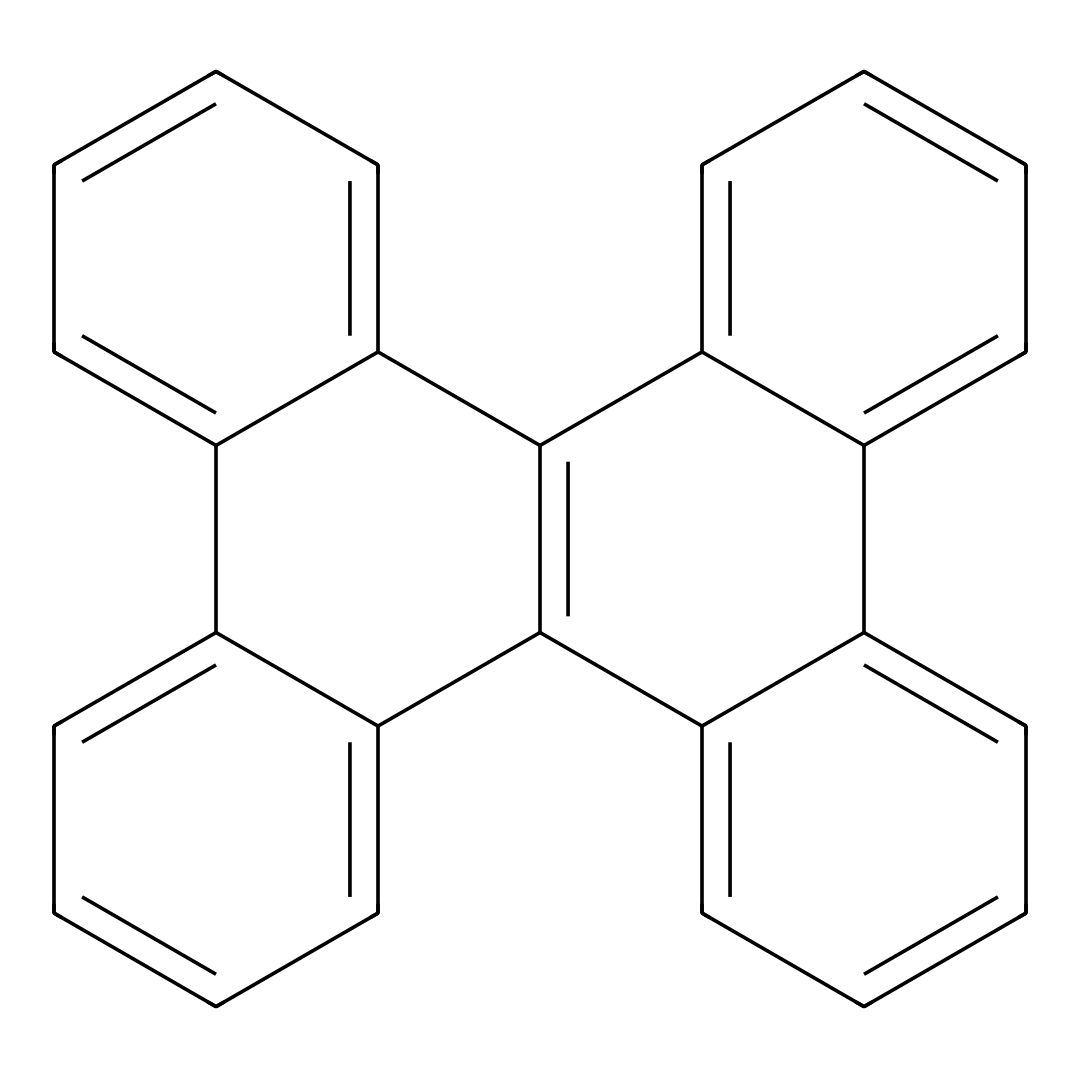What is the molecular formula of the compound? To determine the molecular formula, we count the number of carbon (C) and hydrogen (H) atoms present in the SMILES representation. There are 24 carbon atoms and 12 hydrogen atoms. Therefore, the molecular formula is C24H12.
Answer: C24H12 How many rings are present in the structure? By analyzing the SMILES representation, we can identify that there are six ring closures indicated by the numbers in the SMILES. Each pair of the same number indicates a ring. Thus, there are six rings in total.
Answer: 6 What is the primary function of graphene quantum dots in biomedical imaging? Graphene quantum dots are primarily utilized for their photoluminescence properties and biocompatibility in imaging applications. Their ability to convert light into different wavelengths is key for imaging.
Answer: imaging Is this compound hydrophilic or hydrophobic? Based on the structure's carbon-based composition and the absence of polar functional groups, the compound is hydrophobic, which is typical for many quantum dots used in biomedical applications.
Answer: hydrophobic What type of bonding is predominantly present in the structure? The structure is primarily composed of carbon atoms linked by covalent bonds, a defining feature of organic compounds like graphene quantum dots. Therefore, covalent bonding is predominant.
Answer: covalent What is the expected quantum yield range for graphene quantum dots? Graphene quantum dots typically exhibit a quantum yield in the range of 10% to 40%, depending on their size and surface functionalization. This property is crucial for their effectiveness in imaging applications.
Answer: 10% to 40% 